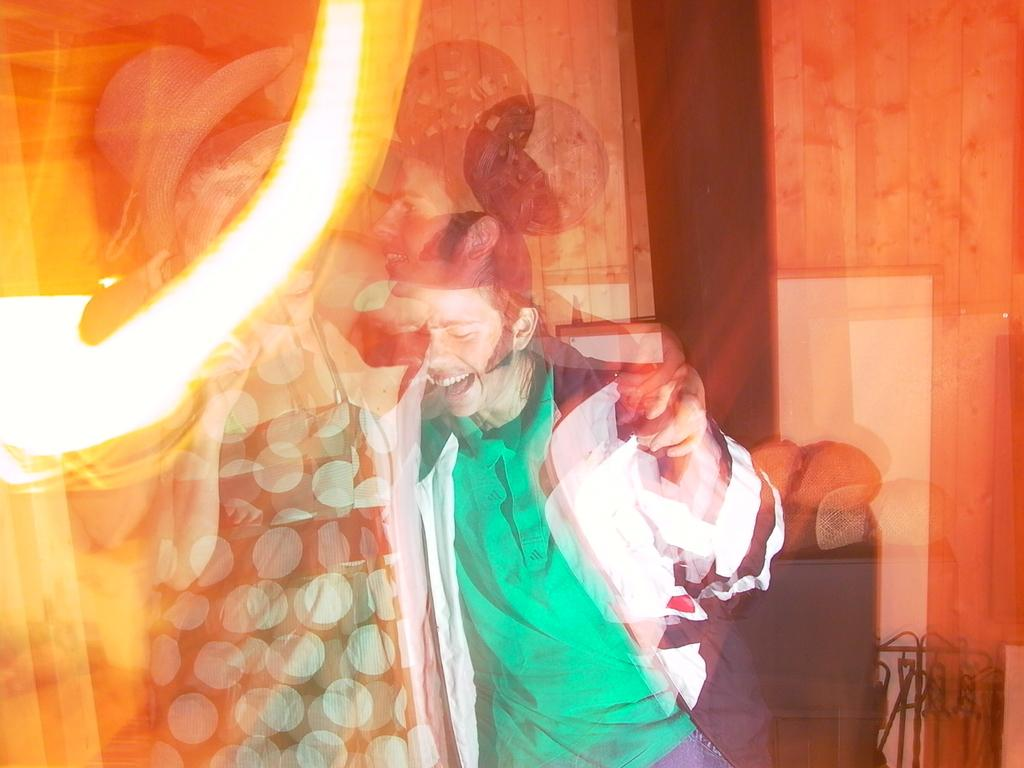How many people are present in the image? There are two persons in the image. What can be seen in the background of the image? There is a wall in the image. What type of furniture is present in the image? There is an almirah and a chair in the image. Is there a volcano erupting in the background of the image? No, there is no volcano present in the image. Can you see a scarecrow standing near the almirah? No, there is no scarecrow present in the image. 